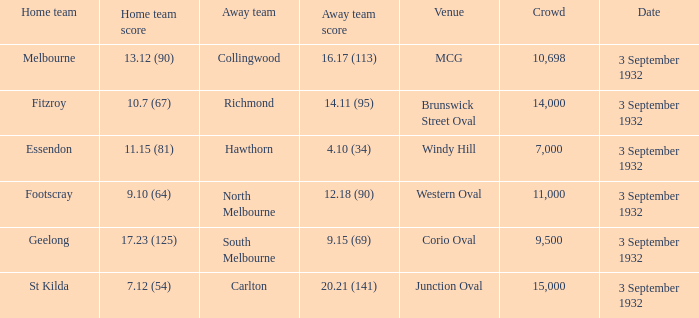What is the name of the Venue for the team that has an Away team score of 14.11 (95)? Brunswick Street Oval. 